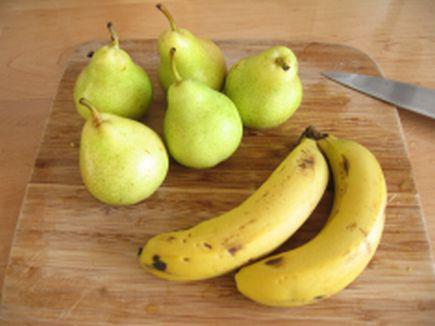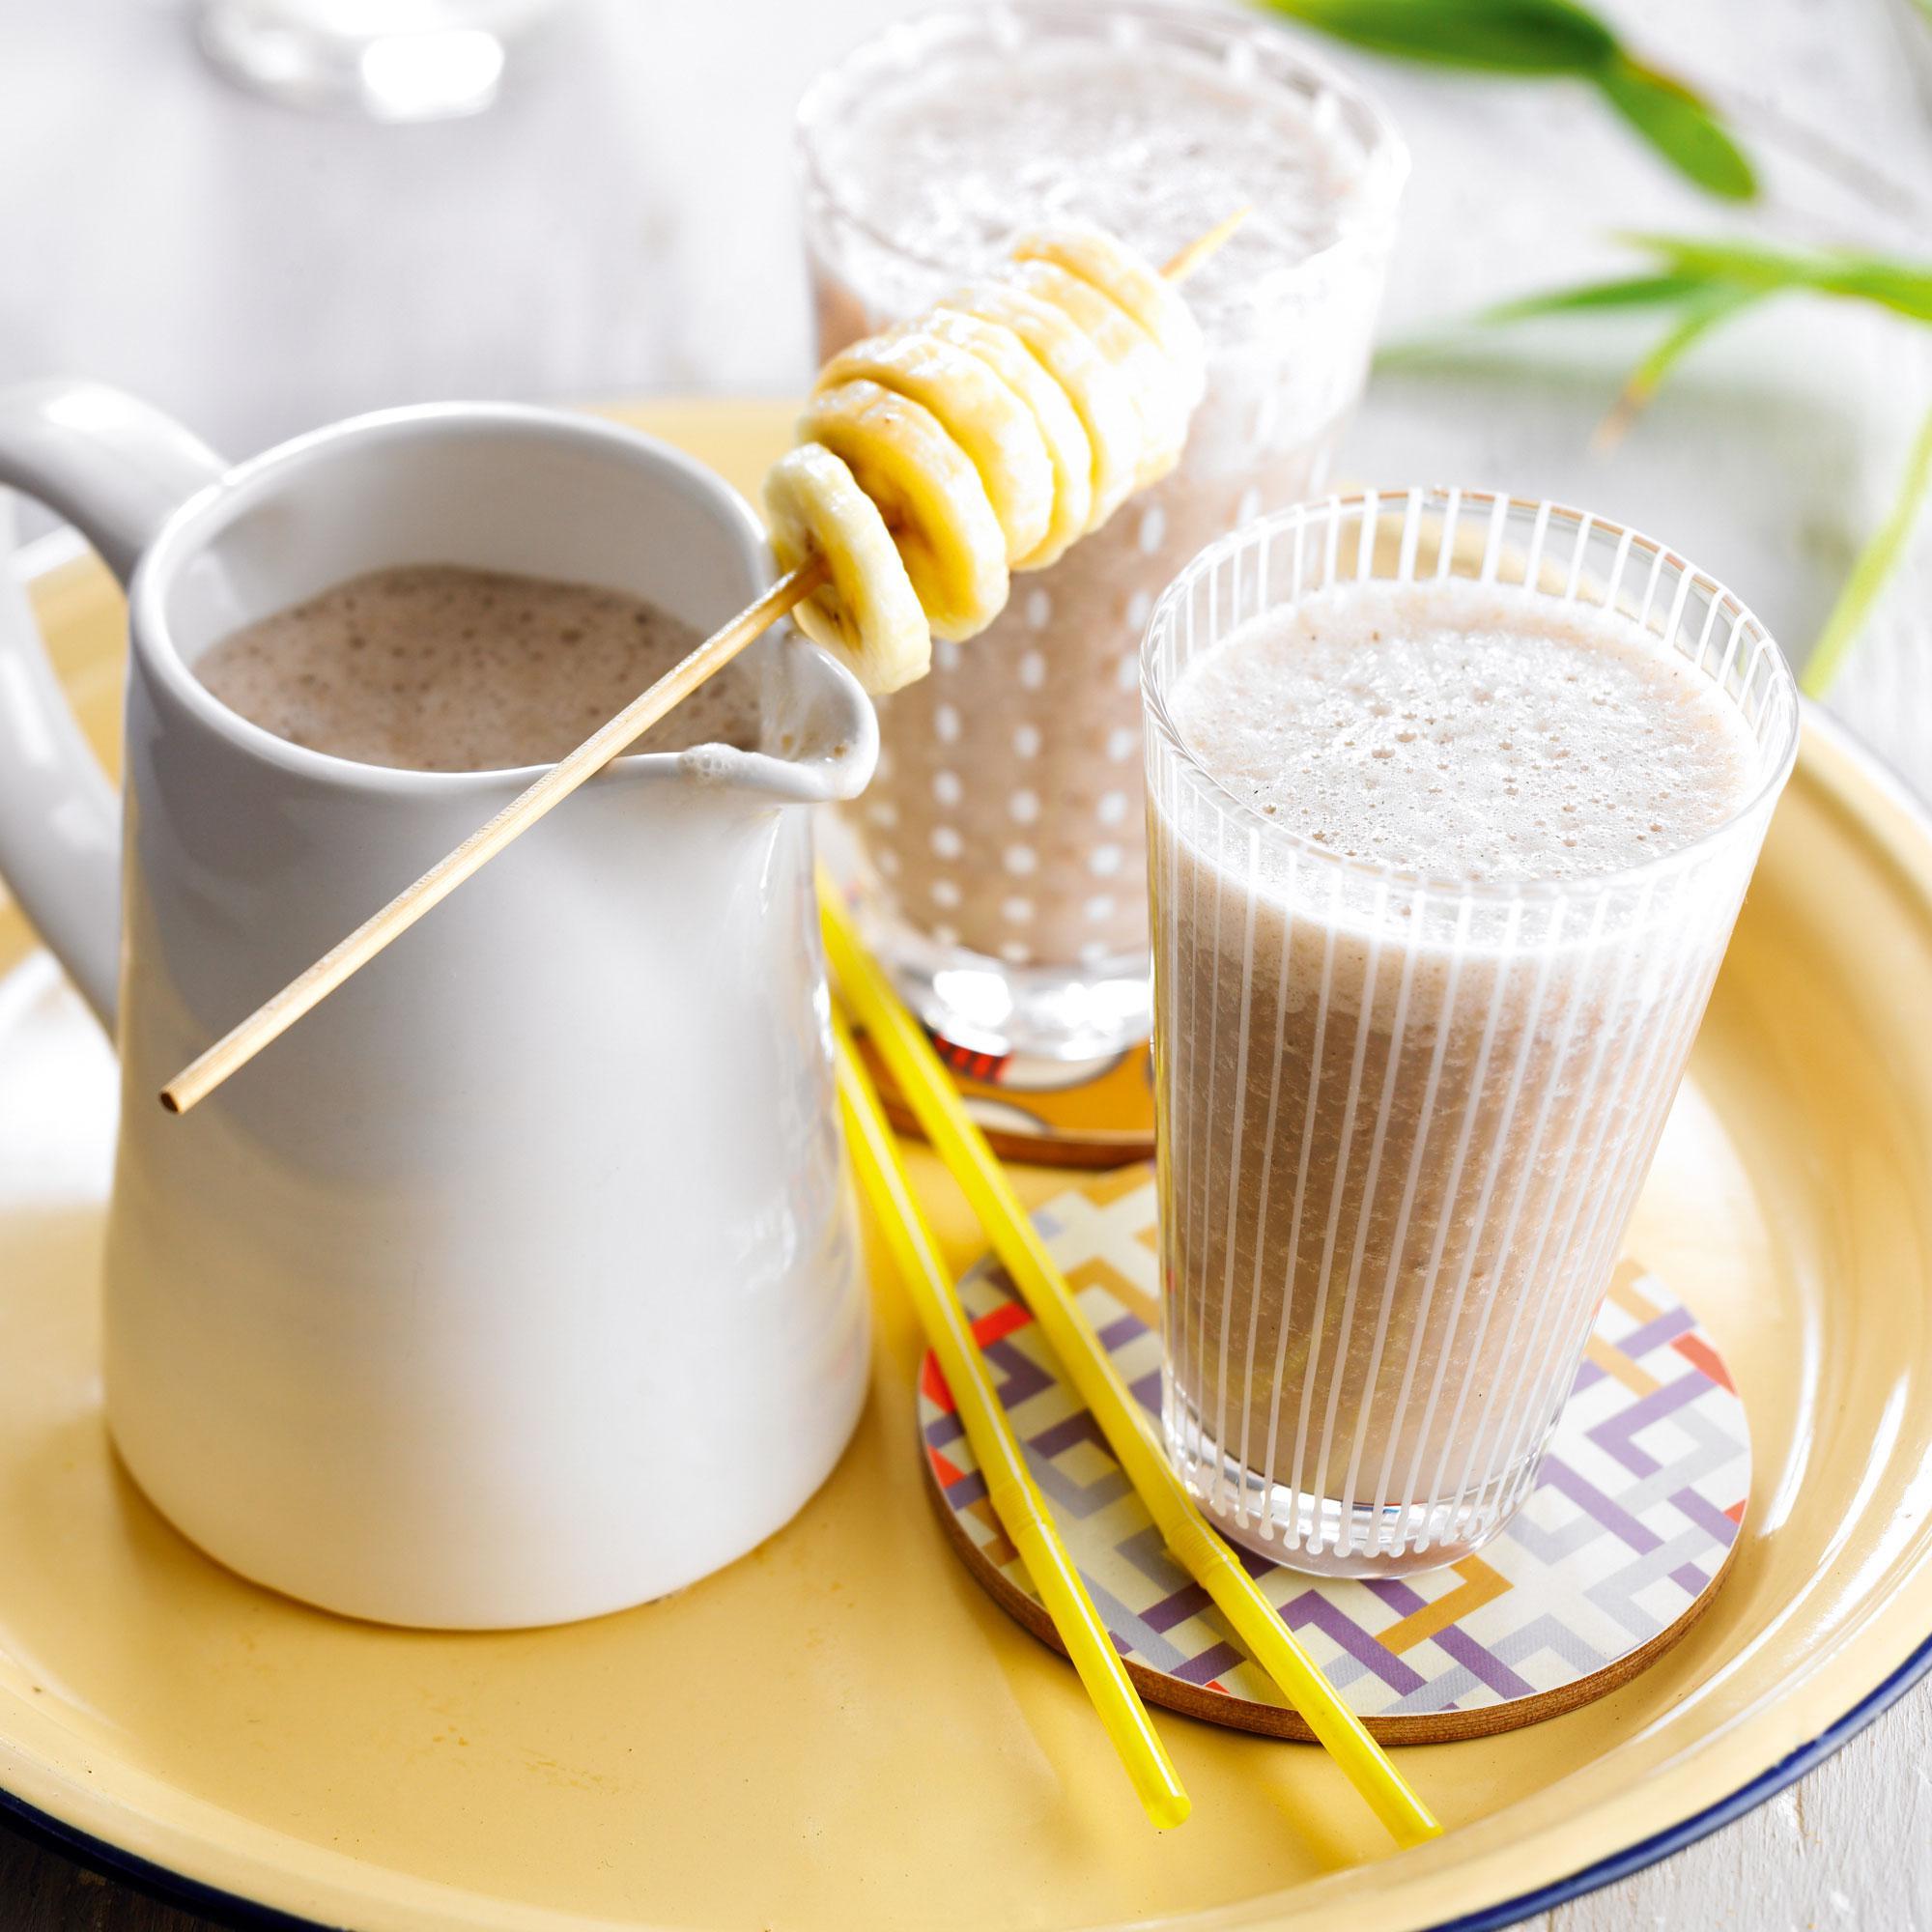The first image is the image on the left, the second image is the image on the right. For the images displayed, is the sentence "An image shows intact banana, pear and beverage." factually correct? Answer yes or no. No. The first image is the image on the left, the second image is the image on the right. Assess this claim about the two images: "In one image, a glass of breakfast drink with a  straw is in front of whole bananas and at least one pear.". Correct or not? Answer yes or no. No. 